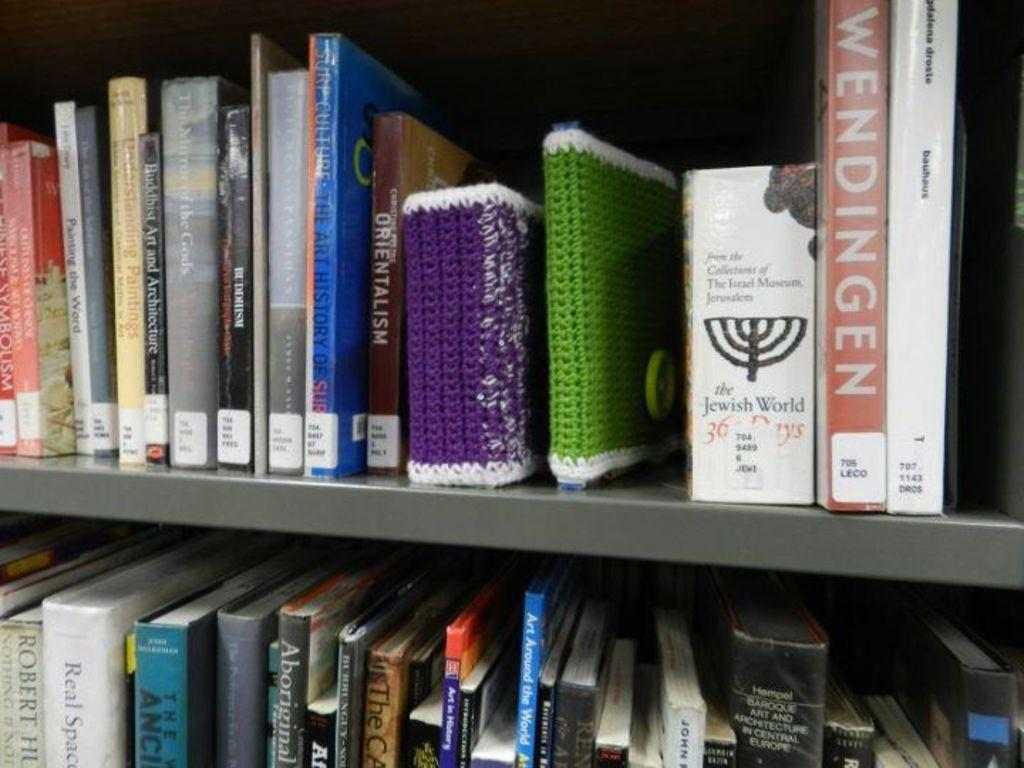Provide a one-sentence caption for the provided image. Shelves of books stacked beside each other with the book Wendingen at the end. 